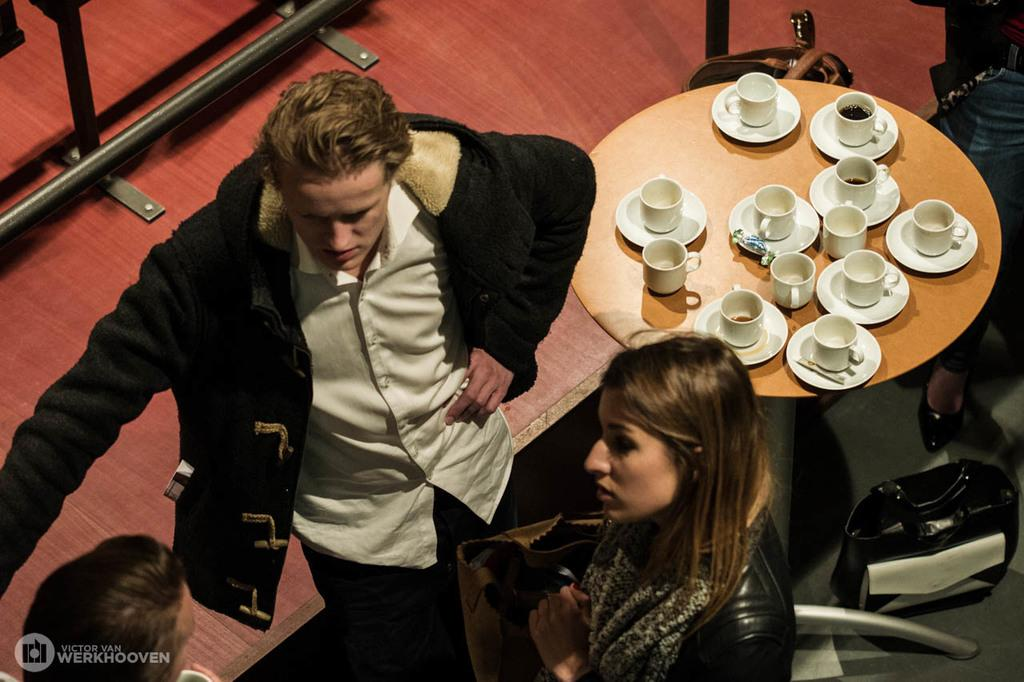How many people are present in the image? There is a man and a woman in the image. What objects can be seen on the table in the image? There are cups and saucers on the table in the image. Can you describe the table in the image? The table is a flat surface with cups and saucers on it. What type of toy is being used to process the bomb in the image? There is no toy, process, or bomb present in the image. 